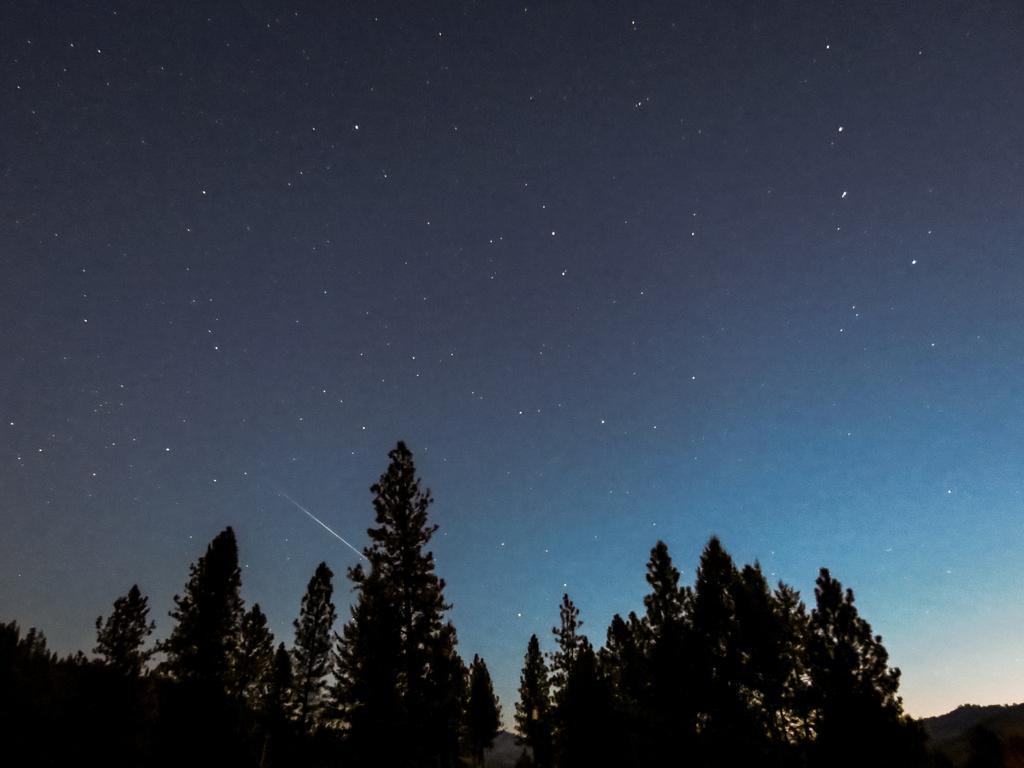What type of surface is visible in the image? There is a grass surface in the image. What can be seen growing on the grass surface? There are trees on the grass surface. What is visible in the background of the image? The sky is visible in the image. What celestial objects can be seen in the sky? Stars are present in the sky. What type of meat is being grilled on the grass surface in the image? There is no meat or grilling activity present in the image; it features a grass surface with trees and a visible sky. 